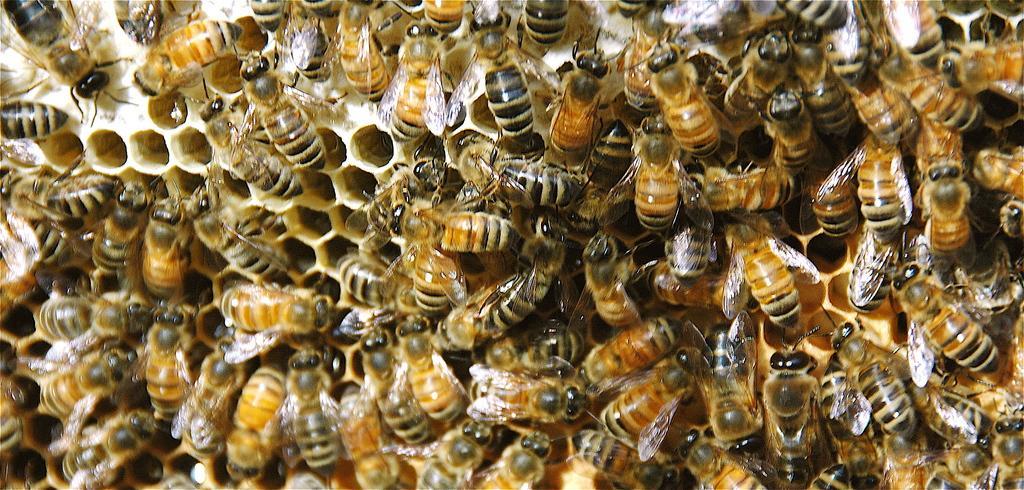Could you give a brief overview of what you see in this image? Here in this picture we can see a bee hive with number of honey bees present on it over there. 